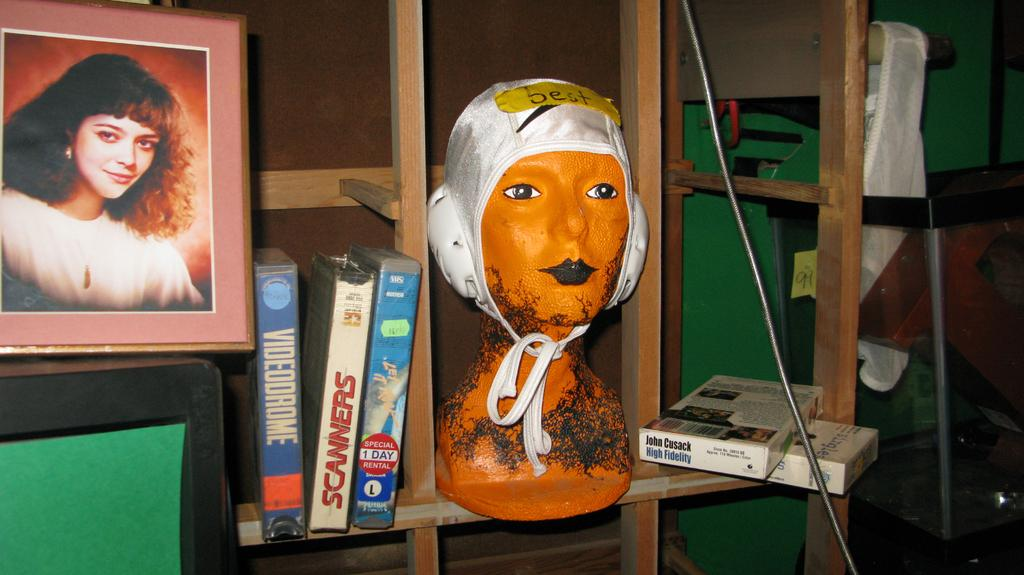What type of objects can be seen in the image? There are CD boxes in the image. What else can be found in the image besides CD boxes? There is a sculpture in the racks in the image. Can you describe the frame on the left side of the image? Yes, there is a frame on the left side of the image. What is visible within the frame? A woman is visible in the frame. How many degrees can be seen in the image? There are no degrees visible in the image. What type of brain is visible in the image? There is no brain present in the image. 